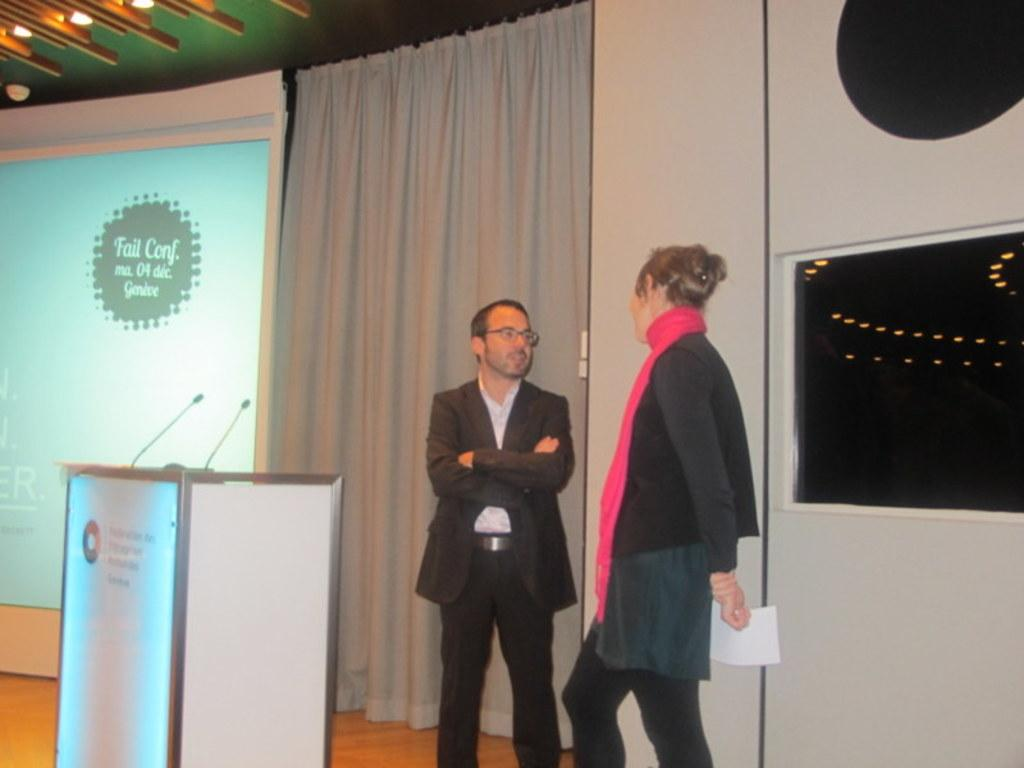<image>
Create a compact narrative representing the image presented. Two people in front of a PowerPoint for a "fail conf." 